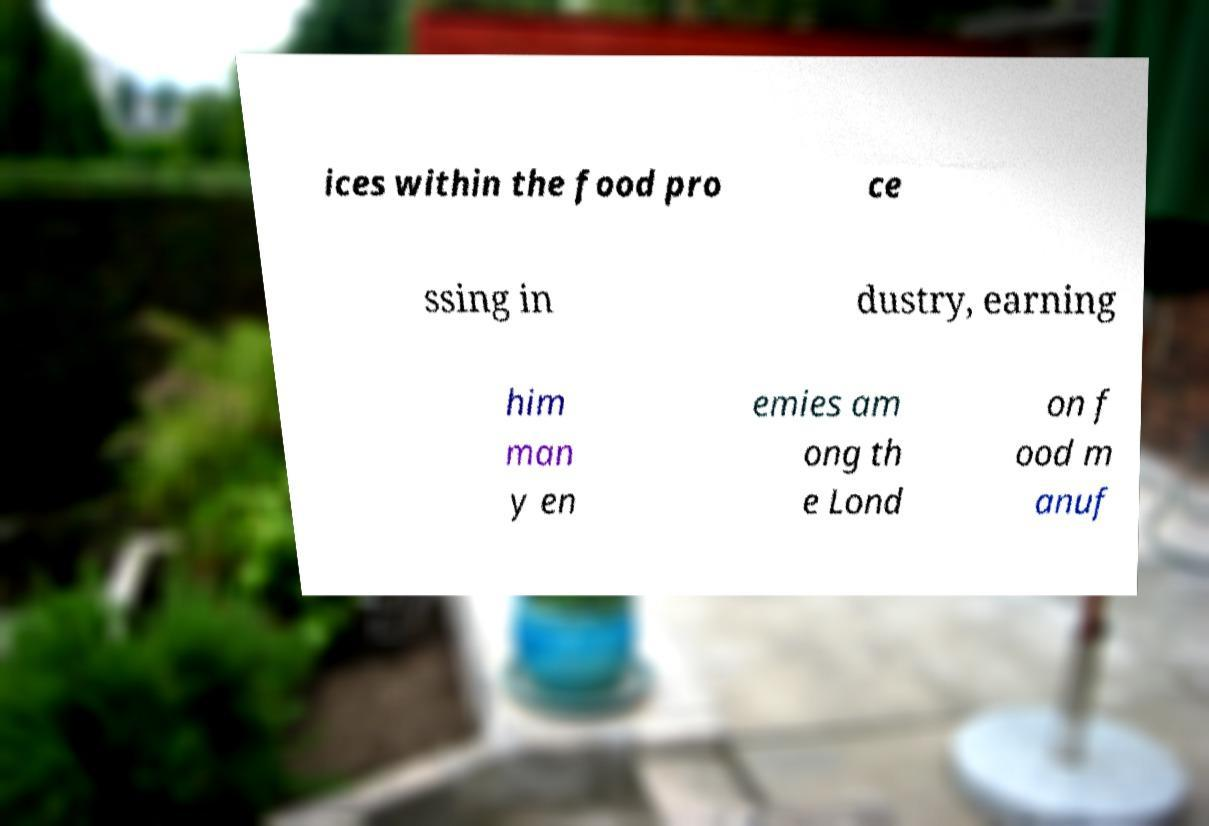Can you accurately transcribe the text from the provided image for me? ices within the food pro ce ssing in dustry, earning him man y en emies am ong th e Lond on f ood m anuf 